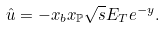<formula> <loc_0><loc_0><loc_500><loc_500>\hat { u } = - x _ { b } x _ { \mathbb { P } } \sqrt { s } E _ { T } e ^ { - y } .</formula> 